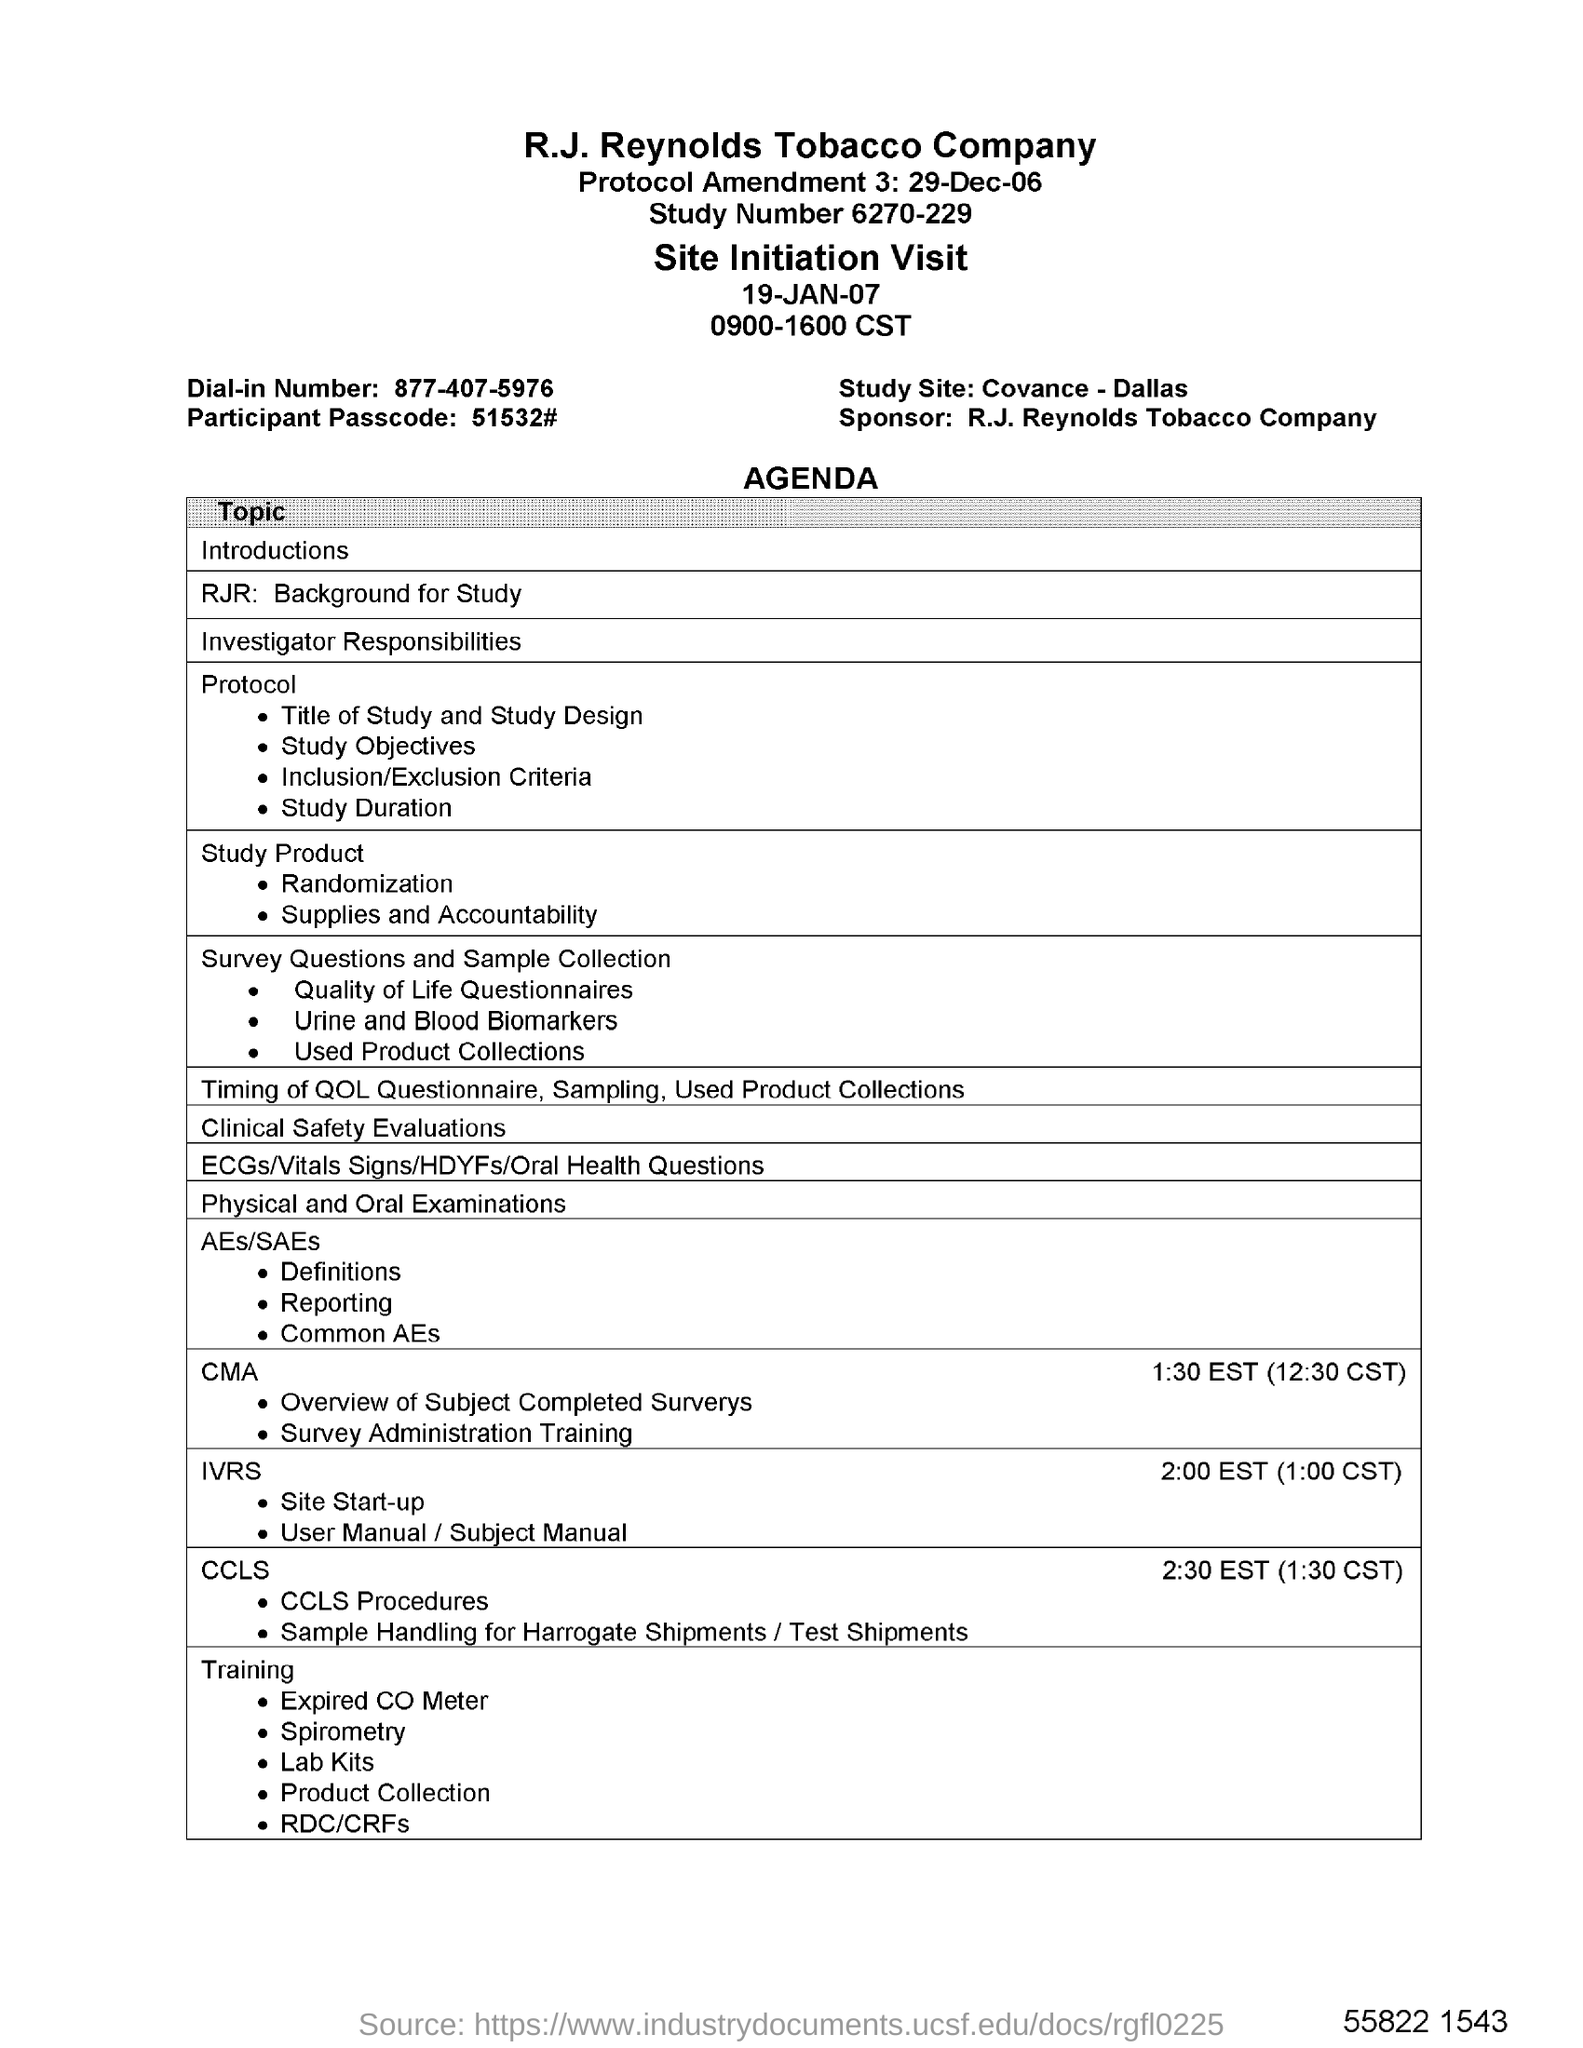Indicate a few pertinent items in this graphic. It is the Covance - Dallas site that is being referred to. What is the Participant Passcode? Please enter the code 51532#... The sponsor is R.J. Reynolds Tobacco Company. What is the Study Number? It is 6270-229. 